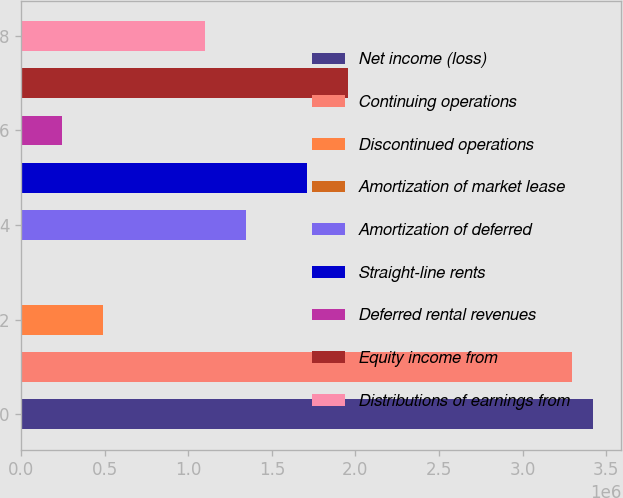Convert chart. <chart><loc_0><loc_0><loc_500><loc_500><bar_chart><fcel>Net income (loss)<fcel>Continuing operations<fcel>Discontinued operations<fcel>Amortization of market lease<fcel>Amortization of deferred<fcel>Straight-line rents<fcel>Deferred rental revenues<fcel>Equity income from<fcel>Distributions of earnings from<nl><fcel>3.41968e+06<fcel>3.29759e+06<fcel>489635<fcel>1295<fcel>1.34423e+06<fcel>1.71048e+06<fcel>245465<fcel>1.95466e+06<fcel>1.10006e+06<nl></chart> 